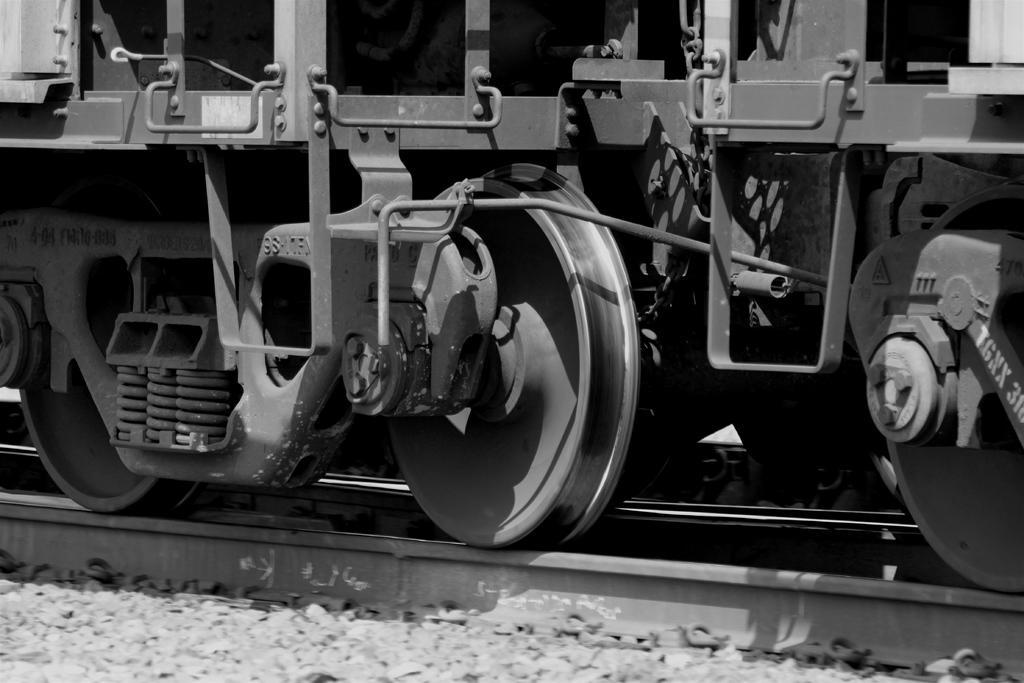In one or two sentences, can you explain what this image depicts? This is a black and white picture and in this picture we can see stones and a train on a railway track. 